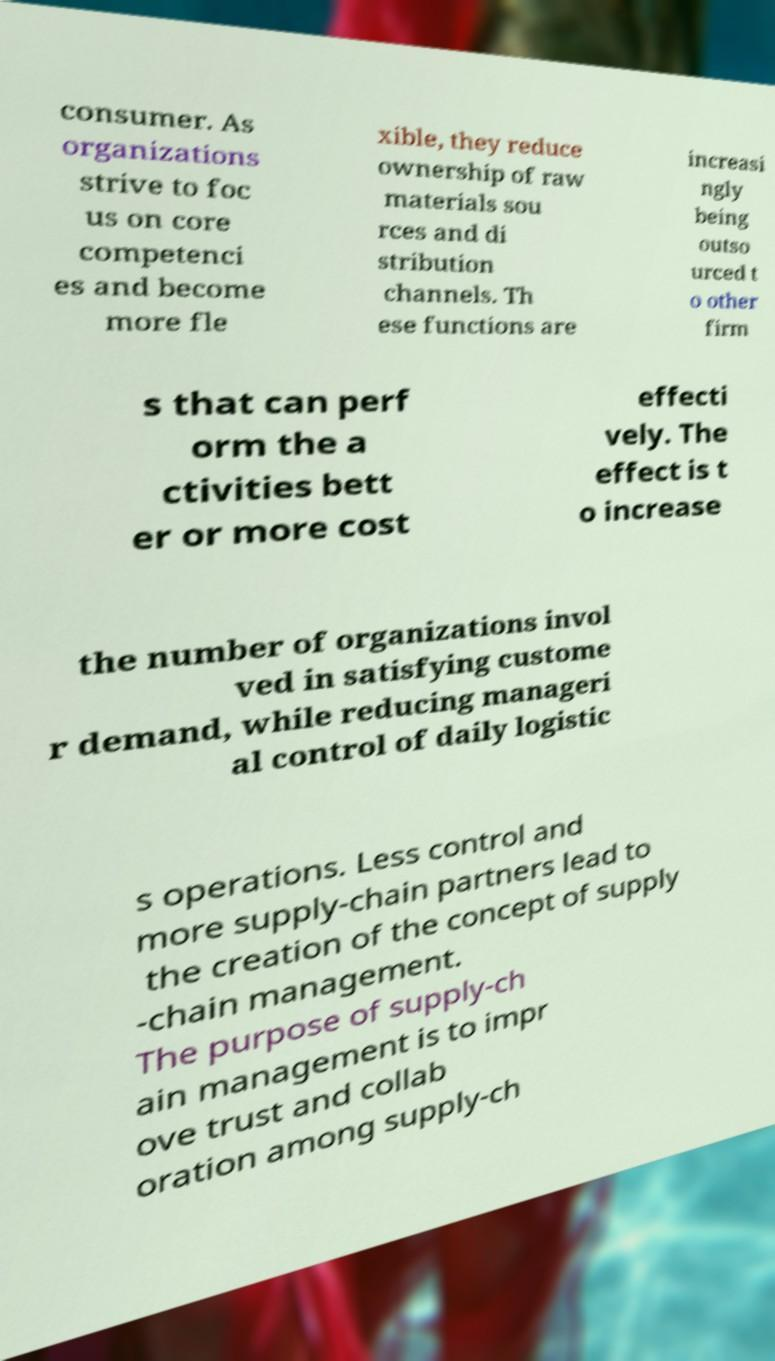Please identify and transcribe the text found in this image. consumer. As organizations strive to foc us on core competenci es and become more fle xible, they reduce ownership of raw materials sou rces and di stribution channels. Th ese functions are increasi ngly being outso urced t o other firm s that can perf orm the a ctivities bett er or more cost effecti vely. The effect is t o increase the number of organizations invol ved in satisfying custome r demand, while reducing manageri al control of daily logistic s operations. Less control and more supply-chain partners lead to the creation of the concept of supply -chain management. The purpose of supply-ch ain management is to impr ove trust and collab oration among supply-ch 